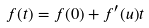<formula> <loc_0><loc_0><loc_500><loc_500>f ( t ) = f ( 0 ) + f ^ { \prime } ( u ) t</formula> 